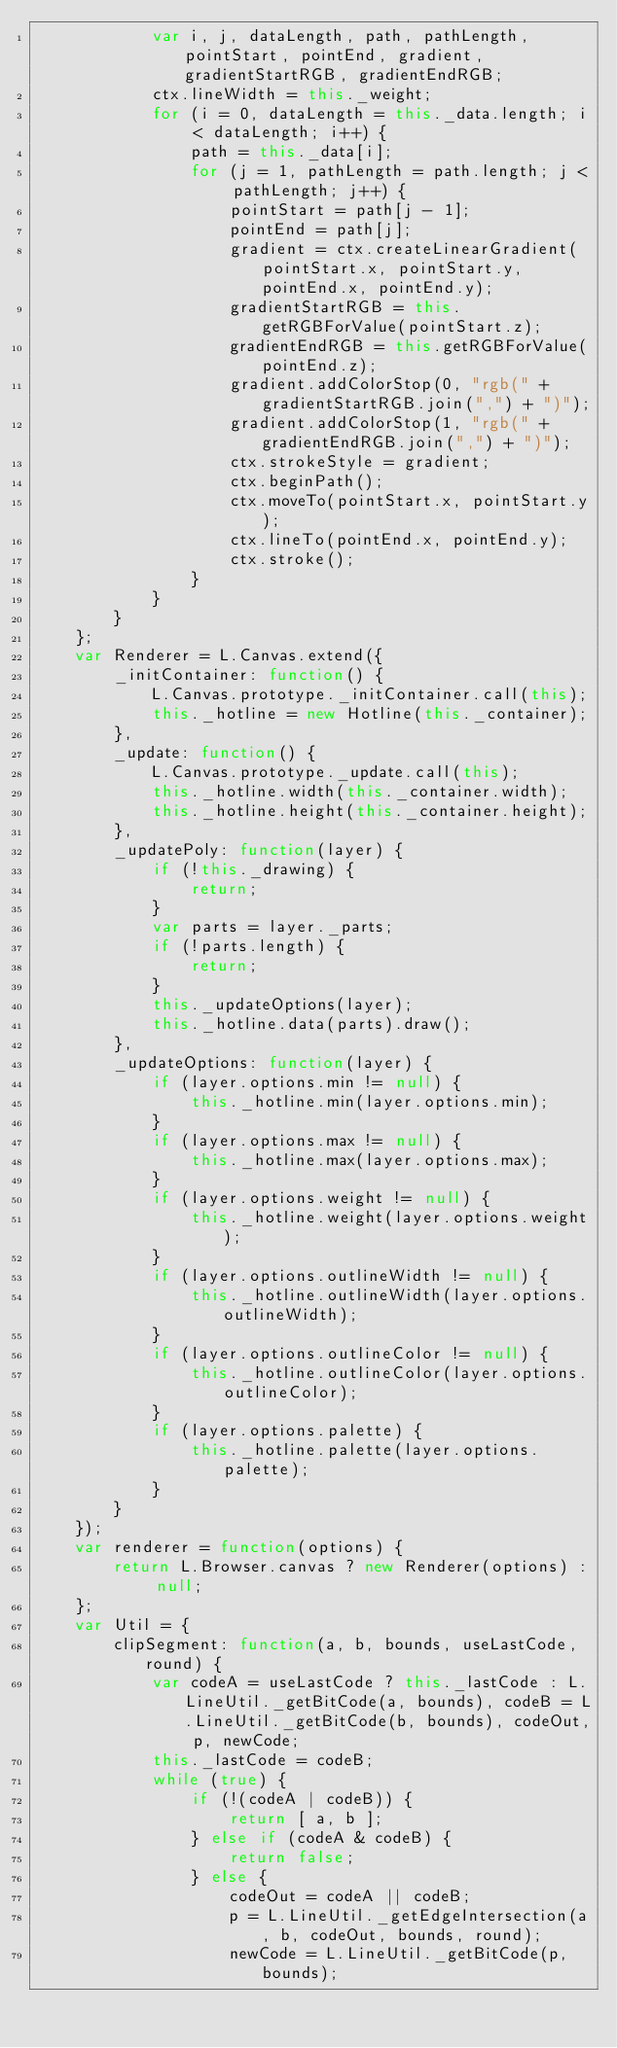<code> <loc_0><loc_0><loc_500><loc_500><_JavaScript_>            var i, j, dataLength, path, pathLength, pointStart, pointEnd, gradient, gradientStartRGB, gradientEndRGB;
            ctx.lineWidth = this._weight;
            for (i = 0, dataLength = this._data.length; i < dataLength; i++) {
                path = this._data[i];
                for (j = 1, pathLength = path.length; j < pathLength; j++) {
                    pointStart = path[j - 1];
                    pointEnd = path[j];
                    gradient = ctx.createLinearGradient(pointStart.x, pointStart.y, pointEnd.x, pointEnd.y);
                    gradientStartRGB = this.getRGBForValue(pointStart.z);
                    gradientEndRGB = this.getRGBForValue(pointEnd.z);
                    gradient.addColorStop(0, "rgb(" + gradientStartRGB.join(",") + ")");
                    gradient.addColorStop(1, "rgb(" + gradientEndRGB.join(",") + ")");
                    ctx.strokeStyle = gradient;
                    ctx.beginPath();
                    ctx.moveTo(pointStart.x, pointStart.y);
                    ctx.lineTo(pointEnd.x, pointEnd.y);
                    ctx.stroke();
                }
            }
        }
    };
    var Renderer = L.Canvas.extend({
        _initContainer: function() {
            L.Canvas.prototype._initContainer.call(this);
            this._hotline = new Hotline(this._container);
        },
        _update: function() {
            L.Canvas.prototype._update.call(this);
            this._hotline.width(this._container.width);
            this._hotline.height(this._container.height);
        },
        _updatePoly: function(layer) {
            if (!this._drawing) {
                return;
            }
            var parts = layer._parts;
            if (!parts.length) {
                return;
            }
            this._updateOptions(layer);
            this._hotline.data(parts).draw();
        },
        _updateOptions: function(layer) {
            if (layer.options.min != null) {
                this._hotline.min(layer.options.min);
            }
            if (layer.options.max != null) {
                this._hotline.max(layer.options.max);
            }
            if (layer.options.weight != null) {
                this._hotline.weight(layer.options.weight);
            }
            if (layer.options.outlineWidth != null) {
                this._hotline.outlineWidth(layer.options.outlineWidth);
            }
            if (layer.options.outlineColor != null) {
                this._hotline.outlineColor(layer.options.outlineColor);
            }
            if (layer.options.palette) {
                this._hotline.palette(layer.options.palette);
            }
        }
    });
    var renderer = function(options) {
        return L.Browser.canvas ? new Renderer(options) : null;
    };
    var Util = {
        clipSegment: function(a, b, bounds, useLastCode, round) {
            var codeA = useLastCode ? this._lastCode : L.LineUtil._getBitCode(a, bounds), codeB = L.LineUtil._getBitCode(b, bounds), codeOut, p, newCode;
            this._lastCode = codeB;
            while (true) {
                if (!(codeA | codeB)) {
                    return [ a, b ];
                } else if (codeA & codeB) {
                    return false;
                } else {
                    codeOut = codeA || codeB;
                    p = L.LineUtil._getEdgeIntersection(a, b, codeOut, bounds, round);
                    newCode = L.LineUtil._getBitCode(p, bounds);</code> 